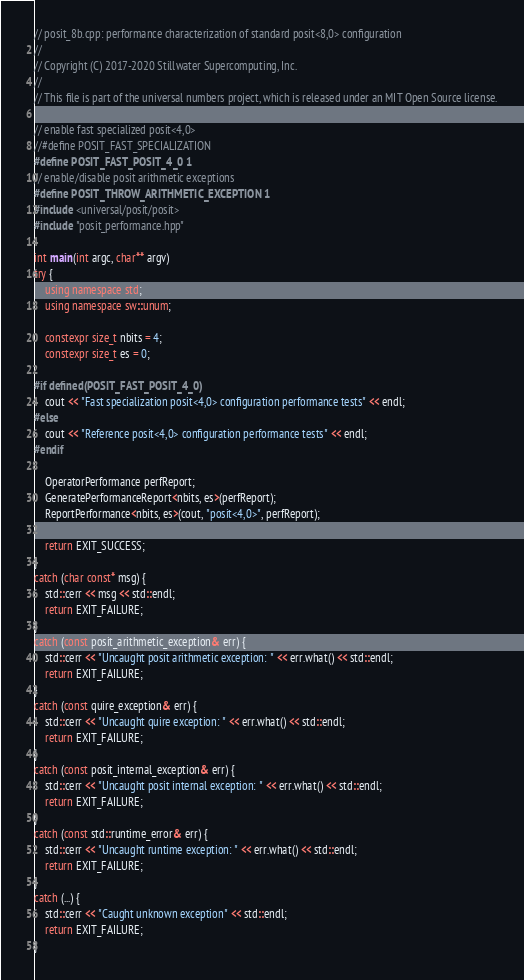<code> <loc_0><loc_0><loc_500><loc_500><_C++_>// posit_8b.cpp: performance characterization of standard posit<8,0> configuration
//
// Copyright (C) 2017-2020 Stillwater Supercomputing, Inc.
//
// This file is part of the universal numbers project, which is released under an MIT Open Source license.

// enable fast specialized posit<4,0>
//#define POSIT_FAST_SPECIALIZATION
#define POSIT_FAST_POSIT_4_0 1
// enable/disable posit arithmetic exceptions
#define POSIT_THROW_ARITHMETIC_EXCEPTION 1
#include <universal/posit/posit>
#include "posit_performance.hpp"

int main(int argc, char** argv)
try {
	using namespace std;
	using namespace sw::unum;

	constexpr size_t nbits = 4;
	constexpr size_t es = 0;

#if defined(POSIT_FAST_POSIT_4_0)
	cout << "Fast specialization posit<4,0> configuration performance tests" << endl;
#else
	cout << "Reference posit<4,0> configuration performance tests" << endl;
#endif

	OperatorPerformance perfReport;
	GeneratePerformanceReport<nbits, es>(perfReport);
	ReportPerformance<nbits, es>(cout, "posit<4,0>", perfReport);

	return EXIT_SUCCESS;
}
catch (char const* msg) {
	std::cerr << msg << std::endl;
	return EXIT_FAILURE;
}
catch (const posit_arithmetic_exception& err) {
	std::cerr << "Uncaught posit arithmetic exception: " << err.what() << std::endl;
	return EXIT_FAILURE;
}
catch (const quire_exception& err) {
	std::cerr << "Uncaught quire exception: " << err.what() << std::endl;
	return EXIT_FAILURE;
}
catch (const posit_internal_exception& err) {
	std::cerr << "Uncaught posit internal exception: " << err.what() << std::endl;
	return EXIT_FAILURE;
}
catch (const std::runtime_error& err) {
	std::cerr << "Uncaught runtime exception: " << err.what() << std::endl;
	return EXIT_FAILURE;
}
catch (...) {
	std::cerr << "Caught unknown exception" << std::endl;
	return EXIT_FAILURE;
}
</code> 